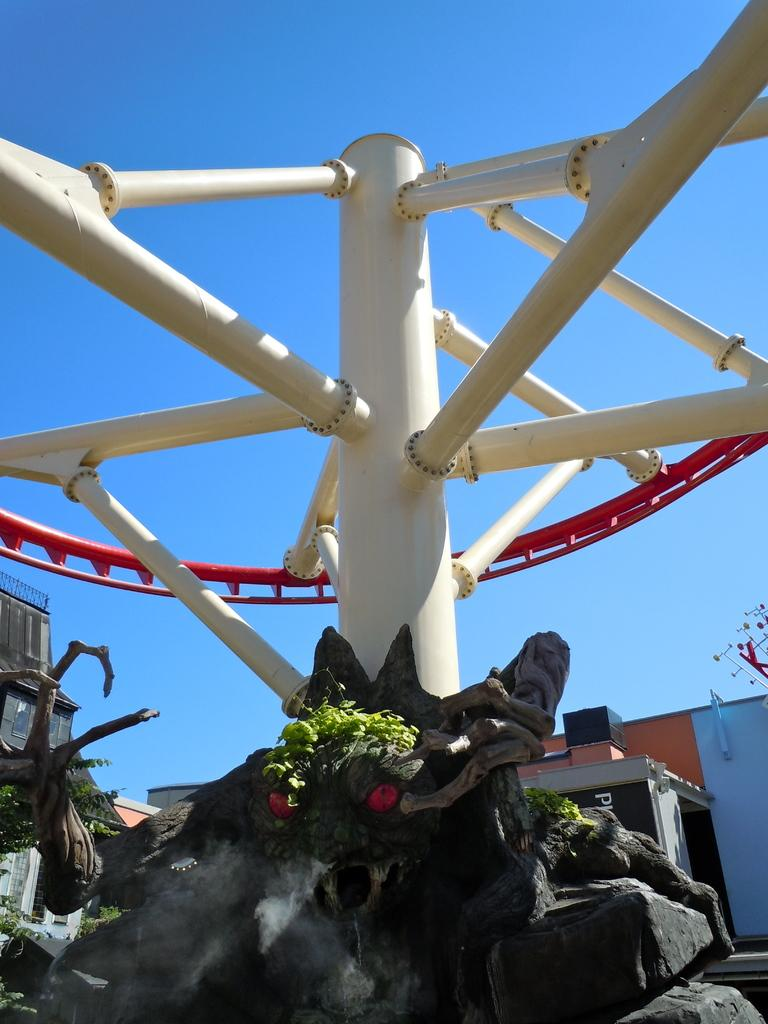What is located on the rock in the image? There is a sculpture on a rock in the image. What can be seen on the sculpture? There are plants and a decorative item with poles on the sculpture. What is visible in the background of the image? There are buildings and the sky visible in the background. What type of powder can be seen covering the bears in the image? There are no bears present in the image, and therefore no powder can be seen covering them. 